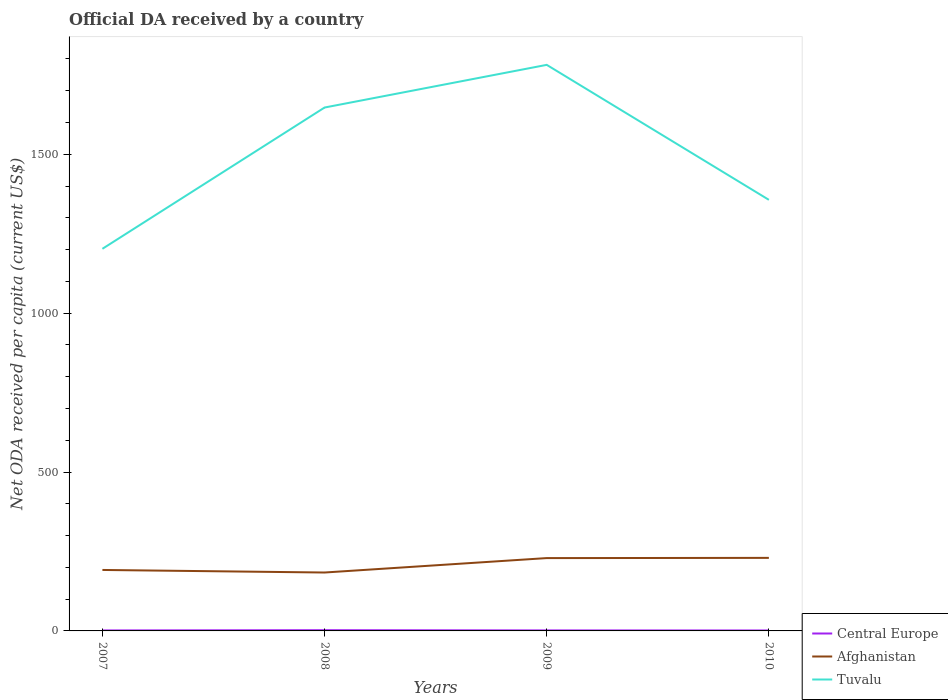Does the line corresponding to Afghanistan intersect with the line corresponding to Central Europe?
Keep it short and to the point. No. Across all years, what is the maximum ODA received in in Tuvalu?
Your answer should be compact. 1202.38. In which year was the ODA received in in Afghanistan maximum?
Your answer should be very brief. 2008. What is the total ODA received in in Afghanistan in the graph?
Offer a terse response. -0.65. What is the difference between the highest and the second highest ODA received in in Tuvalu?
Provide a short and direct response. 578.82. What is the difference between the highest and the lowest ODA received in in Central Europe?
Offer a very short reply. 1. Is the ODA received in in Afghanistan strictly greater than the ODA received in in Central Europe over the years?
Make the answer very short. No. What is the difference between two consecutive major ticks on the Y-axis?
Your answer should be compact. 500. Does the graph contain any zero values?
Provide a succinct answer. No. Does the graph contain grids?
Your answer should be compact. No. What is the title of the graph?
Offer a very short reply. Official DA received by a country. What is the label or title of the X-axis?
Offer a terse response. Years. What is the label or title of the Y-axis?
Ensure brevity in your answer.  Net ODA received per capita (current US$). What is the Net ODA received per capita (current US$) of Central Europe in 2007?
Your response must be concise. 1.54. What is the Net ODA received per capita (current US$) in Afghanistan in 2007?
Keep it short and to the point. 191.85. What is the Net ODA received per capita (current US$) in Tuvalu in 2007?
Offer a very short reply. 1202.38. What is the Net ODA received per capita (current US$) in Central Europe in 2008?
Offer a very short reply. 2.3. What is the Net ODA received per capita (current US$) of Afghanistan in 2008?
Provide a succinct answer. 183.79. What is the Net ODA received per capita (current US$) of Tuvalu in 2008?
Make the answer very short. 1646.91. What is the Net ODA received per capita (current US$) of Central Europe in 2009?
Provide a succinct answer. 1.61. What is the Net ODA received per capita (current US$) of Afghanistan in 2009?
Provide a succinct answer. 229.18. What is the Net ODA received per capita (current US$) of Tuvalu in 2009?
Provide a short and direct response. 1781.2. What is the Net ODA received per capita (current US$) in Central Europe in 2010?
Give a very brief answer. 1.44. What is the Net ODA received per capita (current US$) in Afghanistan in 2010?
Give a very brief answer. 229.83. What is the Net ODA received per capita (current US$) in Tuvalu in 2010?
Offer a terse response. 1356.47. Across all years, what is the maximum Net ODA received per capita (current US$) in Central Europe?
Your answer should be very brief. 2.3. Across all years, what is the maximum Net ODA received per capita (current US$) of Afghanistan?
Ensure brevity in your answer.  229.83. Across all years, what is the maximum Net ODA received per capita (current US$) in Tuvalu?
Provide a short and direct response. 1781.2. Across all years, what is the minimum Net ODA received per capita (current US$) of Central Europe?
Offer a terse response. 1.44. Across all years, what is the minimum Net ODA received per capita (current US$) of Afghanistan?
Ensure brevity in your answer.  183.79. Across all years, what is the minimum Net ODA received per capita (current US$) in Tuvalu?
Offer a terse response. 1202.38. What is the total Net ODA received per capita (current US$) in Central Europe in the graph?
Keep it short and to the point. 6.89. What is the total Net ODA received per capita (current US$) in Afghanistan in the graph?
Keep it short and to the point. 834.65. What is the total Net ODA received per capita (current US$) of Tuvalu in the graph?
Provide a short and direct response. 5986.96. What is the difference between the Net ODA received per capita (current US$) of Central Europe in 2007 and that in 2008?
Offer a very short reply. -0.75. What is the difference between the Net ODA received per capita (current US$) of Afghanistan in 2007 and that in 2008?
Keep it short and to the point. 8.07. What is the difference between the Net ODA received per capita (current US$) of Tuvalu in 2007 and that in 2008?
Offer a terse response. -444.54. What is the difference between the Net ODA received per capita (current US$) in Central Europe in 2007 and that in 2009?
Offer a very short reply. -0.07. What is the difference between the Net ODA received per capita (current US$) in Afghanistan in 2007 and that in 2009?
Provide a short and direct response. -37.33. What is the difference between the Net ODA received per capita (current US$) of Tuvalu in 2007 and that in 2009?
Ensure brevity in your answer.  -578.82. What is the difference between the Net ODA received per capita (current US$) of Central Europe in 2007 and that in 2010?
Provide a short and direct response. 0.1. What is the difference between the Net ODA received per capita (current US$) of Afghanistan in 2007 and that in 2010?
Provide a succinct answer. -37.97. What is the difference between the Net ODA received per capita (current US$) in Tuvalu in 2007 and that in 2010?
Keep it short and to the point. -154.09. What is the difference between the Net ODA received per capita (current US$) in Central Europe in 2008 and that in 2009?
Your answer should be very brief. 0.69. What is the difference between the Net ODA received per capita (current US$) of Afghanistan in 2008 and that in 2009?
Your response must be concise. -45.39. What is the difference between the Net ODA received per capita (current US$) of Tuvalu in 2008 and that in 2009?
Keep it short and to the point. -134.28. What is the difference between the Net ODA received per capita (current US$) of Central Europe in 2008 and that in 2010?
Provide a succinct answer. 0.86. What is the difference between the Net ODA received per capita (current US$) in Afghanistan in 2008 and that in 2010?
Ensure brevity in your answer.  -46.04. What is the difference between the Net ODA received per capita (current US$) in Tuvalu in 2008 and that in 2010?
Provide a short and direct response. 290.45. What is the difference between the Net ODA received per capita (current US$) in Central Europe in 2009 and that in 2010?
Make the answer very short. 0.17. What is the difference between the Net ODA received per capita (current US$) of Afghanistan in 2009 and that in 2010?
Give a very brief answer. -0.65. What is the difference between the Net ODA received per capita (current US$) in Tuvalu in 2009 and that in 2010?
Provide a short and direct response. 424.73. What is the difference between the Net ODA received per capita (current US$) in Central Europe in 2007 and the Net ODA received per capita (current US$) in Afghanistan in 2008?
Your response must be concise. -182.24. What is the difference between the Net ODA received per capita (current US$) in Central Europe in 2007 and the Net ODA received per capita (current US$) in Tuvalu in 2008?
Your answer should be compact. -1645.37. What is the difference between the Net ODA received per capita (current US$) in Afghanistan in 2007 and the Net ODA received per capita (current US$) in Tuvalu in 2008?
Your answer should be very brief. -1455.06. What is the difference between the Net ODA received per capita (current US$) in Central Europe in 2007 and the Net ODA received per capita (current US$) in Afghanistan in 2009?
Ensure brevity in your answer.  -227.64. What is the difference between the Net ODA received per capita (current US$) in Central Europe in 2007 and the Net ODA received per capita (current US$) in Tuvalu in 2009?
Keep it short and to the point. -1779.65. What is the difference between the Net ODA received per capita (current US$) in Afghanistan in 2007 and the Net ODA received per capita (current US$) in Tuvalu in 2009?
Ensure brevity in your answer.  -1589.34. What is the difference between the Net ODA received per capita (current US$) of Central Europe in 2007 and the Net ODA received per capita (current US$) of Afghanistan in 2010?
Offer a very short reply. -228.28. What is the difference between the Net ODA received per capita (current US$) of Central Europe in 2007 and the Net ODA received per capita (current US$) of Tuvalu in 2010?
Your answer should be compact. -1354.92. What is the difference between the Net ODA received per capita (current US$) of Afghanistan in 2007 and the Net ODA received per capita (current US$) of Tuvalu in 2010?
Keep it short and to the point. -1164.61. What is the difference between the Net ODA received per capita (current US$) of Central Europe in 2008 and the Net ODA received per capita (current US$) of Afghanistan in 2009?
Offer a terse response. -226.88. What is the difference between the Net ODA received per capita (current US$) of Central Europe in 2008 and the Net ODA received per capita (current US$) of Tuvalu in 2009?
Keep it short and to the point. -1778.9. What is the difference between the Net ODA received per capita (current US$) of Afghanistan in 2008 and the Net ODA received per capita (current US$) of Tuvalu in 2009?
Provide a short and direct response. -1597.41. What is the difference between the Net ODA received per capita (current US$) of Central Europe in 2008 and the Net ODA received per capita (current US$) of Afghanistan in 2010?
Offer a terse response. -227.53. What is the difference between the Net ODA received per capita (current US$) of Central Europe in 2008 and the Net ODA received per capita (current US$) of Tuvalu in 2010?
Your response must be concise. -1354.17. What is the difference between the Net ODA received per capita (current US$) in Afghanistan in 2008 and the Net ODA received per capita (current US$) in Tuvalu in 2010?
Your answer should be compact. -1172.68. What is the difference between the Net ODA received per capita (current US$) of Central Europe in 2009 and the Net ODA received per capita (current US$) of Afghanistan in 2010?
Offer a terse response. -228.22. What is the difference between the Net ODA received per capita (current US$) of Central Europe in 2009 and the Net ODA received per capita (current US$) of Tuvalu in 2010?
Offer a very short reply. -1354.86. What is the difference between the Net ODA received per capita (current US$) in Afghanistan in 2009 and the Net ODA received per capita (current US$) in Tuvalu in 2010?
Make the answer very short. -1127.29. What is the average Net ODA received per capita (current US$) of Central Europe per year?
Make the answer very short. 1.72. What is the average Net ODA received per capita (current US$) in Afghanistan per year?
Give a very brief answer. 208.66. What is the average Net ODA received per capita (current US$) in Tuvalu per year?
Your answer should be very brief. 1496.74. In the year 2007, what is the difference between the Net ODA received per capita (current US$) in Central Europe and Net ODA received per capita (current US$) in Afghanistan?
Give a very brief answer. -190.31. In the year 2007, what is the difference between the Net ODA received per capita (current US$) of Central Europe and Net ODA received per capita (current US$) of Tuvalu?
Ensure brevity in your answer.  -1200.83. In the year 2007, what is the difference between the Net ODA received per capita (current US$) in Afghanistan and Net ODA received per capita (current US$) in Tuvalu?
Give a very brief answer. -1010.52. In the year 2008, what is the difference between the Net ODA received per capita (current US$) in Central Europe and Net ODA received per capita (current US$) in Afghanistan?
Offer a very short reply. -181.49. In the year 2008, what is the difference between the Net ODA received per capita (current US$) of Central Europe and Net ODA received per capita (current US$) of Tuvalu?
Ensure brevity in your answer.  -1644.62. In the year 2008, what is the difference between the Net ODA received per capita (current US$) in Afghanistan and Net ODA received per capita (current US$) in Tuvalu?
Ensure brevity in your answer.  -1463.13. In the year 2009, what is the difference between the Net ODA received per capita (current US$) of Central Europe and Net ODA received per capita (current US$) of Afghanistan?
Provide a short and direct response. -227.57. In the year 2009, what is the difference between the Net ODA received per capita (current US$) in Central Europe and Net ODA received per capita (current US$) in Tuvalu?
Your answer should be very brief. -1779.59. In the year 2009, what is the difference between the Net ODA received per capita (current US$) of Afghanistan and Net ODA received per capita (current US$) of Tuvalu?
Offer a terse response. -1552.02. In the year 2010, what is the difference between the Net ODA received per capita (current US$) of Central Europe and Net ODA received per capita (current US$) of Afghanistan?
Give a very brief answer. -228.39. In the year 2010, what is the difference between the Net ODA received per capita (current US$) of Central Europe and Net ODA received per capita (current US$) of Tuvalu?
Offer a terse response. -1355.03. In the year 2010, what is the difference between the Net ODA received per capita (current US$) of Afghanistan and Net ODA received per capita (current US$) of Tuvalu?
Provide a short and direct response. -1126.64. What is the ratio of the Net ODA received per capita (current US$) in Central Europe in 2007 to that in 2008?
Offer a terse response. 0.67. What is the ratio of the Net ODA received per capita (current US$) of Afghanistan in 2007 to that in 2008?
Offer a terse response. 1.04. What is the ratio of the Net ODA received per capita (current US$) in Tuvalu in 2007 to that in 2008?
Provide a short and direct response. 0.73. What is the ratio of the Net ODA received per capita (current US$) in Central Europe in 2007 to that in 2009?
Ensure brevity in your answer.  0.96. What is the ratio of the Net ODA received per capita (current US$) in Afghanistan in 2007 to that in 2009?
Your answer should be compact. 0.84. What is the ratio of the Net ODA received per capita (current US$) of Tuvalu in 2007 to that in 2009?
Offer a very short reply. 0.68. What is the ratio of the Net ODA received per capita (current US$) of Central Europe in 2007 to that in 2010?
Keep it short and to the point. 1.07. What is the ratio of the Net ODA received per capita (current US$) in Afghanistan in 2007 to that in 2010?
Make the answer very short. 0.83. What is the ratio of the Net ODA received per capita (current US$) of Tuvalu in 2007 to that in 2010?
Offer a very short reply. 0.89. What is the ratio of the Net ODA received per capita (current US$) in Central Europe in 2008 to that in 2009?
Keep it short and to the point. 1.43. What is the ratio of the Net ODA received per capita (current US$) of Afghanistan in 2008 to that in 2009?
Your answer should be compact. 0.8. What is the ratio of the Net ODA received per capita (current US$) of Tuvalu in 2008 to that in 2009?
Make the answer very short. 0.92. What is the ratio of the Net ODA received per capita (current US$) in Central Europe in 2008 to that in 2010?
Your response must be concise. 1.59. What is the ratio of the Net ODA received per capita (current US$) of Afghanistan in 2008 to that in 2010?
Your answer should be compact. 0.8. What is the ratio of the Net ODA received per capita (current US$) in Tuvalu in 2008 to that in 2010?
Your answer should be very brief. 1.21. What is the ratio of the Net ODA received per capita (current US$) of Central Europe in 2009 to that in 2010?
Provide a short and direct response. 1.12. What is the ratio of the Net ODA received per capita (current US$) in Tuvalu in 2009 to that in 2010?
Your answer should be very brief. 1.31. What is the difference between the highest and the second highest Net ODA received per capita (current US$) in Central Europe?
Ensure brevity in your answer.  0.69. What is the difference between the highest and the second highest Net ODA received per capita (current US$) in Afghanistan?
Your response must be concise. 0.65. What is the difference between the highest and the second highest Net ODA received per capita (current US$) in Tuvalu?
Your response must be concise. 134.28. What is the difference between the highest and the lowest Net ODA received per capita (current US$) in Central Europe?
Offer a terse response. 0.86. What is the difference between the highest and the lowest Net ODA received per capita (current US$) in Afghanistan?
Your answer should be very brief. 46.04. What is the difference between the highest and the lowest Net ODA received per capita (current US$) in Tuvalu?
Provide a succinct answer. 578.82. 